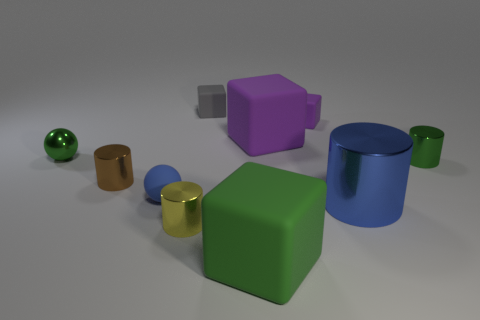Subtract all tiny green cylinders. How many cylinders are left? 3 Subtract all green cylinders. How many cylinders are left? 3 Subtract all spheres. How many objects are left? 8 Subtract 0 red cubes. How many objects are left? 10 Subtract 3 cylinders. How many cylinders are left? 1 Subtract all gray balls. Subtract all brown cubes. How many balls are left? 2 Subtract all gray cylinders. How many purple cubes are left? 2 Subtract all red things. Subtract all big green blocks. How many objects are left? 9 Add 7 big blue cylinders. How many big blue cylinders are left? 8 Add 6 gray cylinders. How many gray cylinders exist? 6 